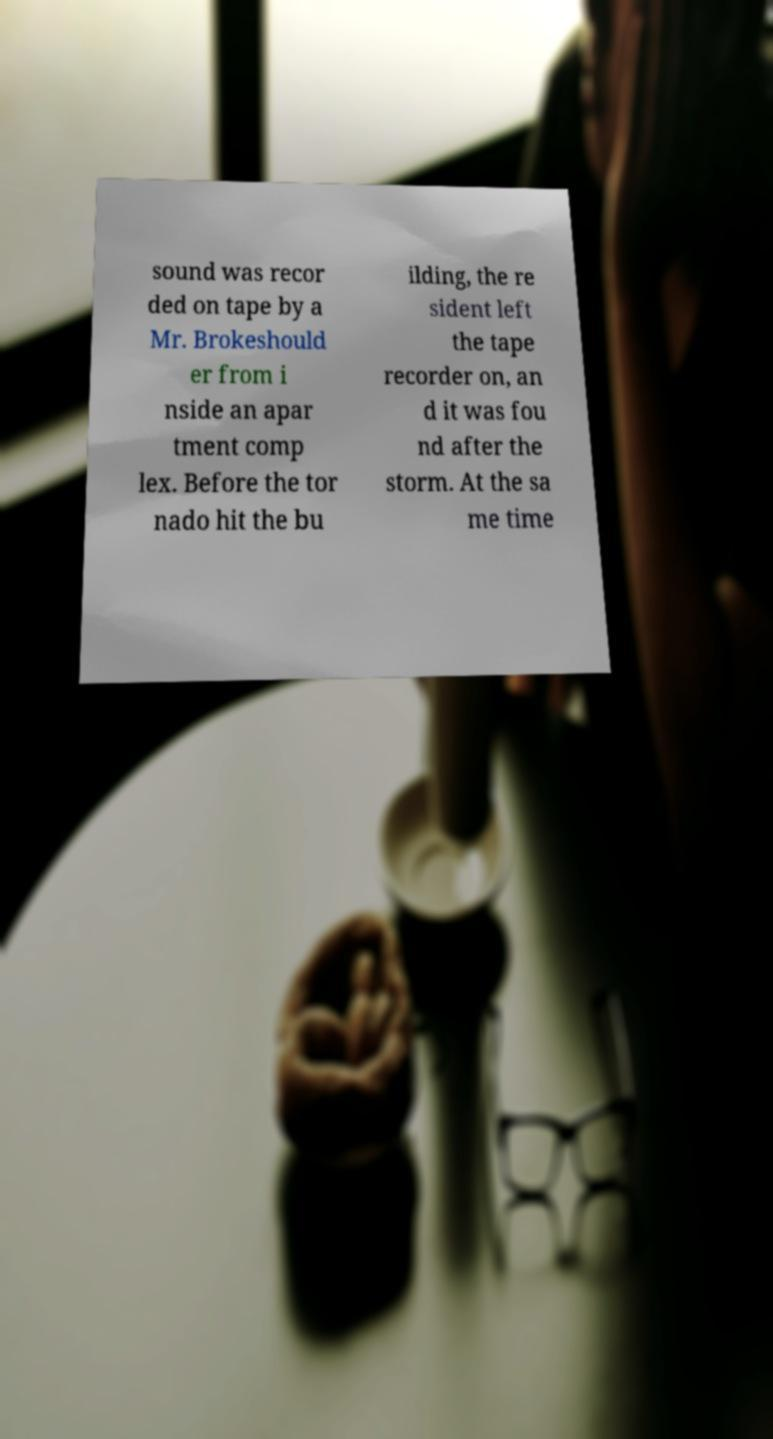Can you accurately transcribe the text from the provided image for me? sound was recor ded on tape by a Mr. Brokeshould er from i nside an apar tment comp lex. Before the tor nado hit the bu ilding, the re sident left the tape recorder on, an d it was fou nd after the storm. At the sa me time 